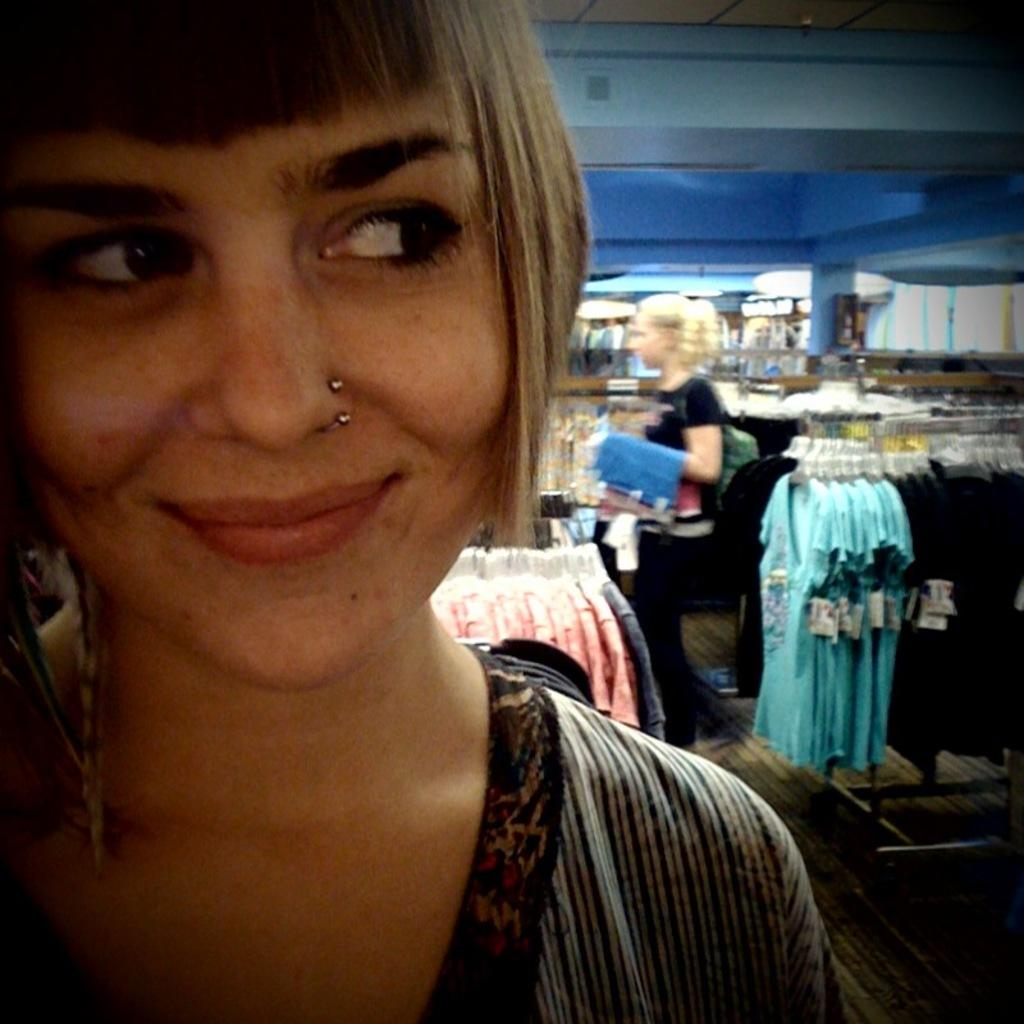How many people are in the image? There are two people in the image. What is the second person holding? The second person is holding clothes. What can be seen around the people in the image? Clothes are present on hangers around the people. What direction is the cork being pushed in the image? There is no cork present in the image. Who is the representative of the group in the image? The image does not depict a group or a representative. 